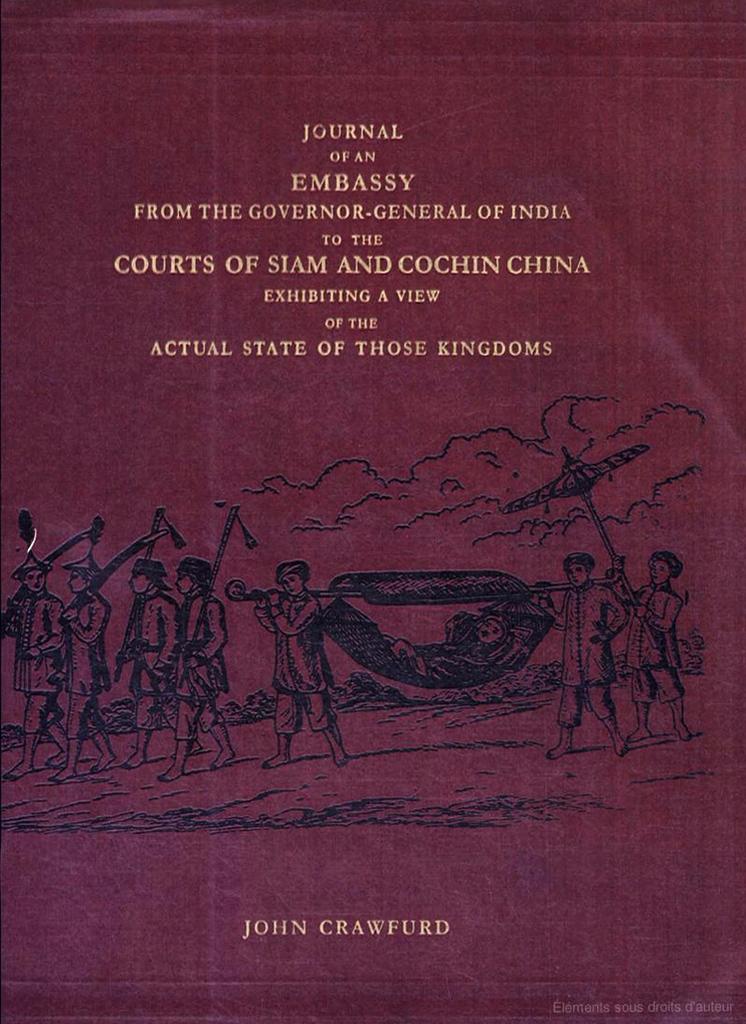What is this book about?
Ensure brevity in your answer.  Journal of an embassy. Who is the author of the book?
Make the answer very short. John crawfurd. 